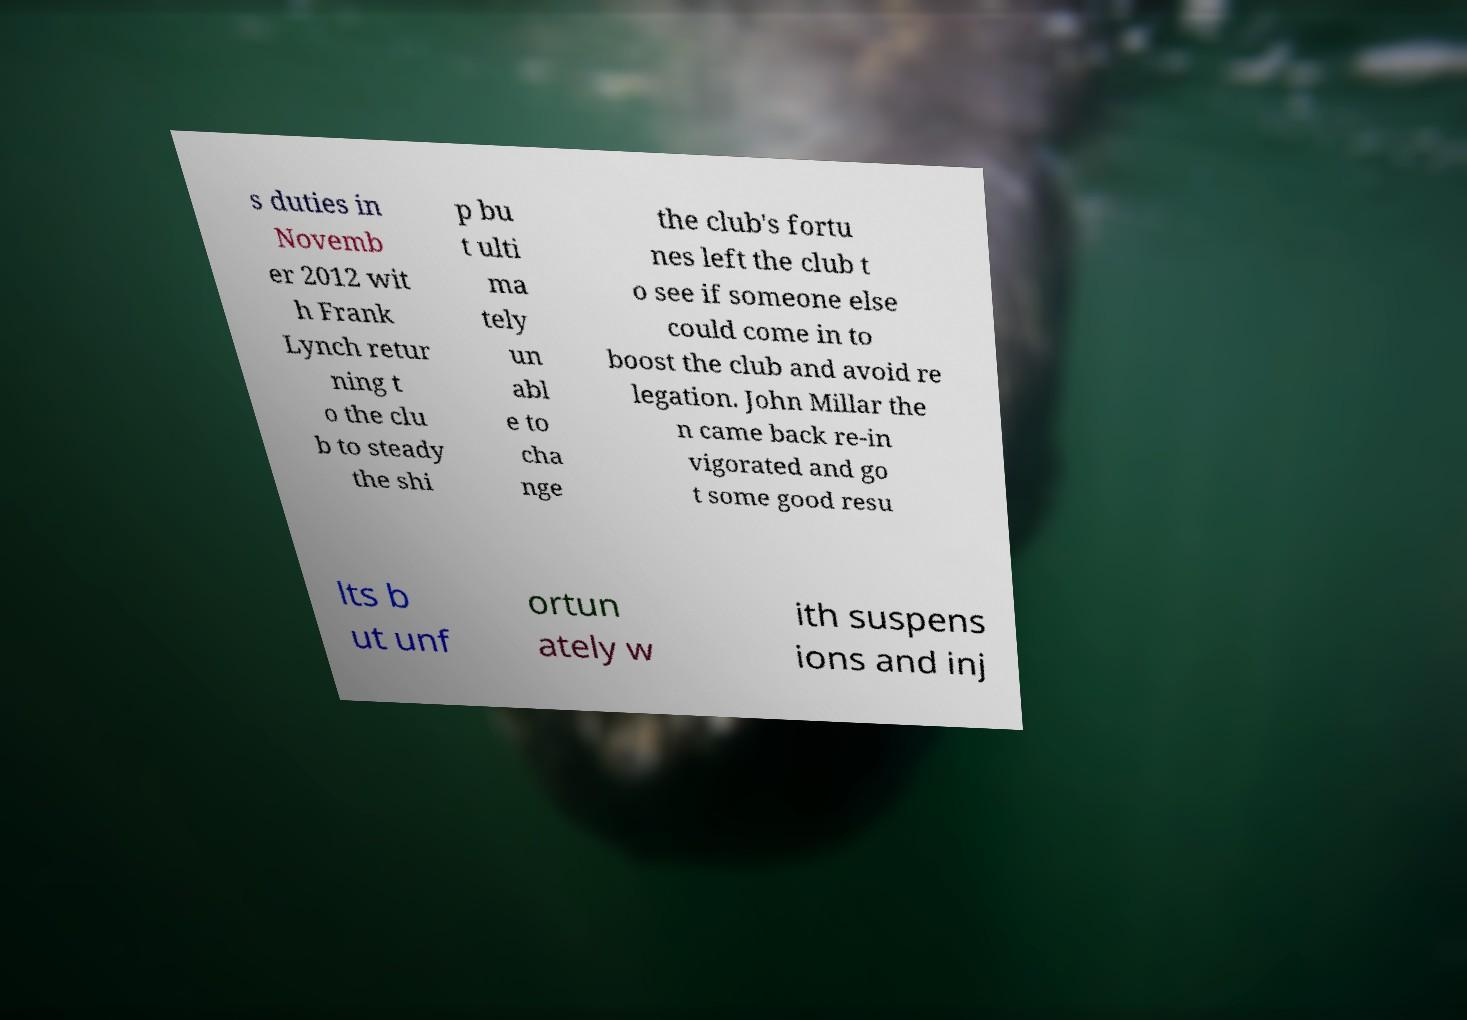Can you read and provide the text displayed in the image?This photo seems to have some interesting text. Can you extract and type it out for me? s duties in Novemb er 2012 wit h Frank Lynch retur ning t o the clu b to steady the shi p bu t ulti ma tely un abl e to cha nge the club's fortu nes left the club t o see if someone else could come in to boost the club and avoid re legation. John Millar the n came back re-in vigorated and go t some good resu lts b ut unf ortun ately w ith suspens ions and inj 